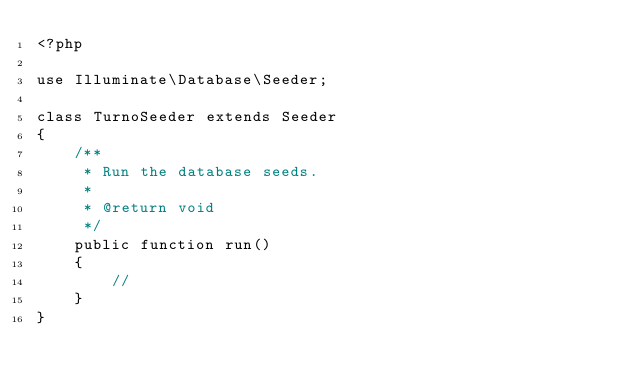Convert code to text. <code><loc_0><loc_0><loc_500><loc_500><_PHP_><?php

use Illuminate\Database\Seeder;

class TurnoSeeder extends Seeder
{
    /**
     * Run the database seeds.
     *
     * @return void
     */
    public function run()
    {
        //
    }
}
</code> 